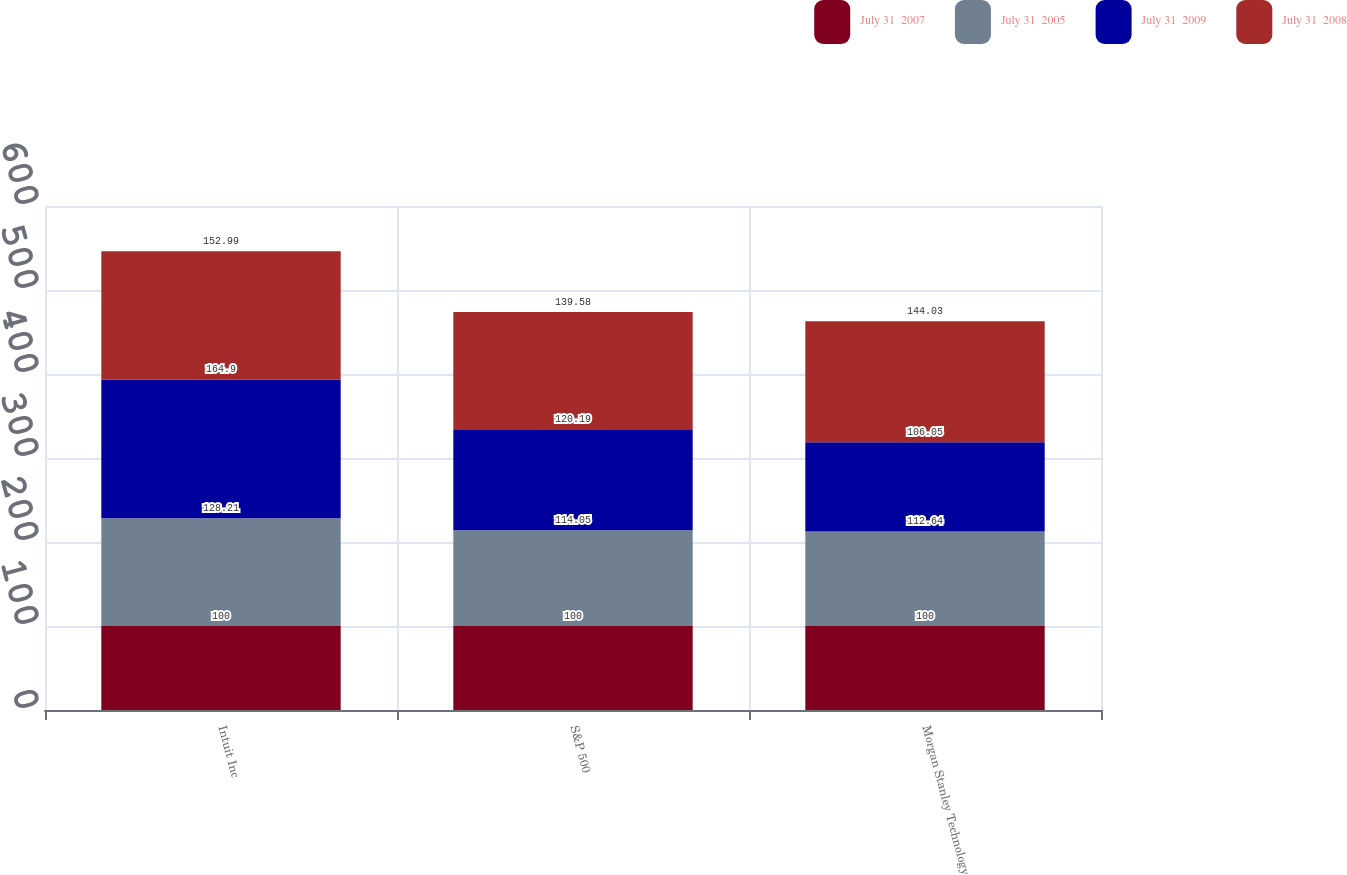Convert chart to OTSL. <chart><loc_0><loc_0><loc_500><loc_500><stacked_bar_chart><ecel><fcel>Intuit Inc<fcel>S&P 500<fcel>Morgan Stanley Technology<nl><fcel>July 31  2007<fcel>100<fcel>100<fcel>100<nl><fcel>July 31  2005<fcel>128.21<fcel>114.05<fcel>112.64<nl><fcel>July 31  2009<fcel>164.9<fcel>120.19<fcel>106.05<nl><fcel>July 31  2008<fcel>152.99<fcel>139.58<fcel>144.03<nl></chart> 